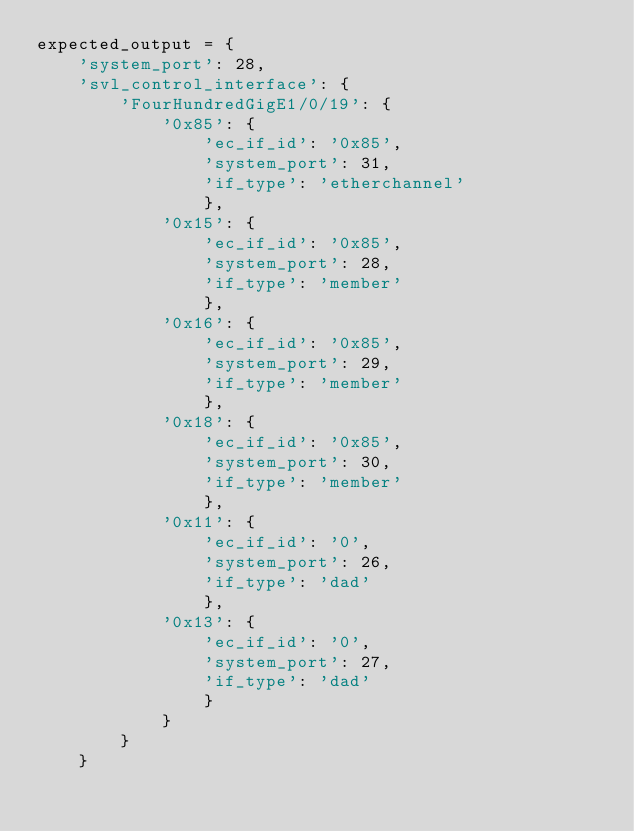Convert code to text. <code><loc_0><loc_0><loc_500><loc_500><_Python_>expected_output = {
    'system_port': 28,
	'svl_control_interface': {
	    'FourHundredGigE1/0/19': {
		    '0x85': {
			    'ec_if_id': '0x85',
				'system_port': 31,
				'if_type': 'etherchannel'
				},
			'0x15': {
			    'ec_if_id': '0x85', 
				'system_port': 28, 
				'if_type': 'member'
				},
			'0x16': {
			    'ec_if_id': '0x85', 
				'system_port': 29, 
				'if_type': 'member'
				},
			'0x18': {
			    'ec_if_id': '0x85', 
				'system_port': 30, 
				'if_type': 'member'
				},
			'0x11': {
			    'ec_if_id': '0', 
				'system_port': 26, 
				'if_type': 'dad'
				},
			'0x13': {
			    'ec_if_id': '0', 
				'system_port': 27, 
				'if_type': 'dad'
			    }
		    }
	    }
    }
</code> 